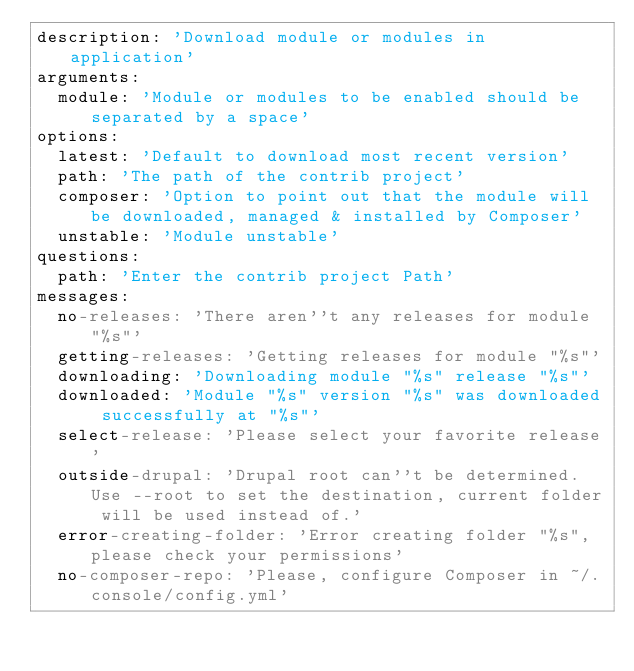<code> <loc_0><loc_0><loc_500><loc_500><_YAML_>description: 'Download module or modules in application'
arguments:
  module: 'Module or modules to be enabled should be separated by a space'
options:
  latest: 'Default to download most recent version'
  path: 'The path of the contrib project'
  composer: 'Option to point out that the module will be downloaded, managed & installed by Composer'
  unstable: 'Module unstable'
questions:
  path: 'Enter the contrib project Path'
messages:
  no-releases: 'There aren''t any releases for module "%s"'
  getting-releases: 'Getting releases for module "%s"'
  downloading: 'Downloading module "%s" release "%s"'
  downloaded: 'Module "%s" version "%s" was downloaded successfully at "%s"'
  select-release: 'Please select your favorite release'
  outside-drupal: 'Drupal root can''t be determined. Use --root to set the destination, current folder will be used instead of.'
  error-creating-folder: 'Error creating folder "%s", please check your permissions'
  no-composer-repo: 'Please, configure Composer in ~/.console/config.yml'</code> 